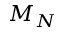Convert formula to latex. <formula><loc_0><loc_0><loc_500><loc_500>M _ { N }</formula> 